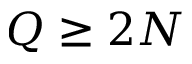<formula> <loc_0><loc_0><loc_500><loc_500>Q \geq 2 N</formula> 